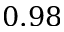Convert formula to latex. <formula><loc_0><loc_0><loc_500><loc_500>0 . 9 8</formula> 